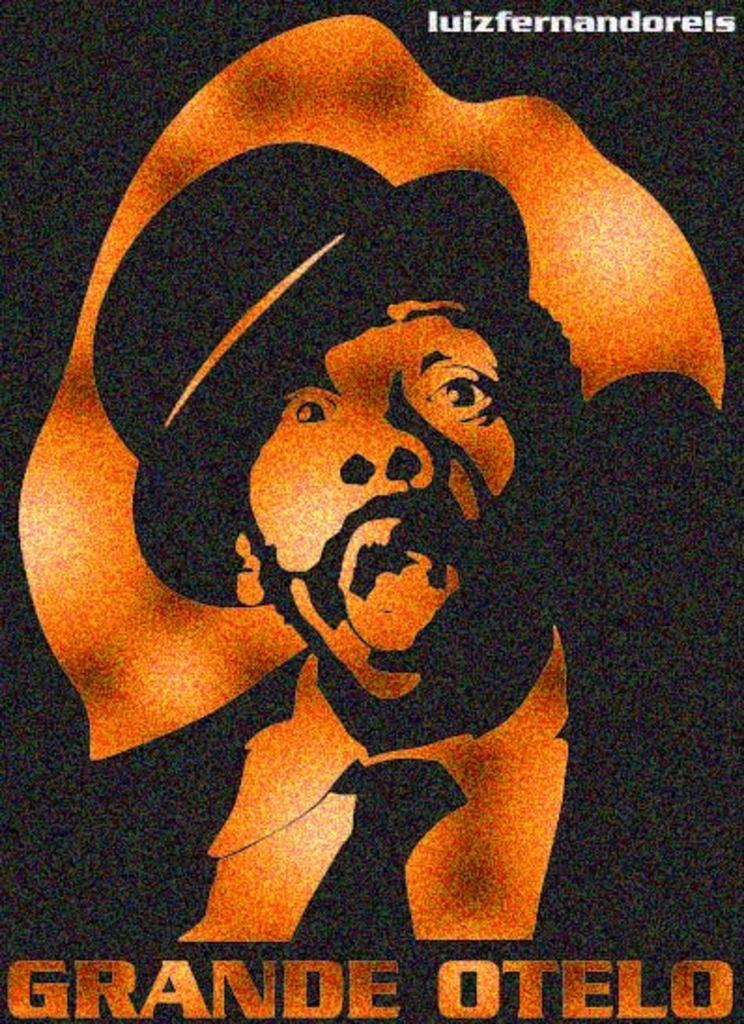<image>
Relay a brief, clear account of the picture shown. A poster of a man with the caption Grande Otelo. 